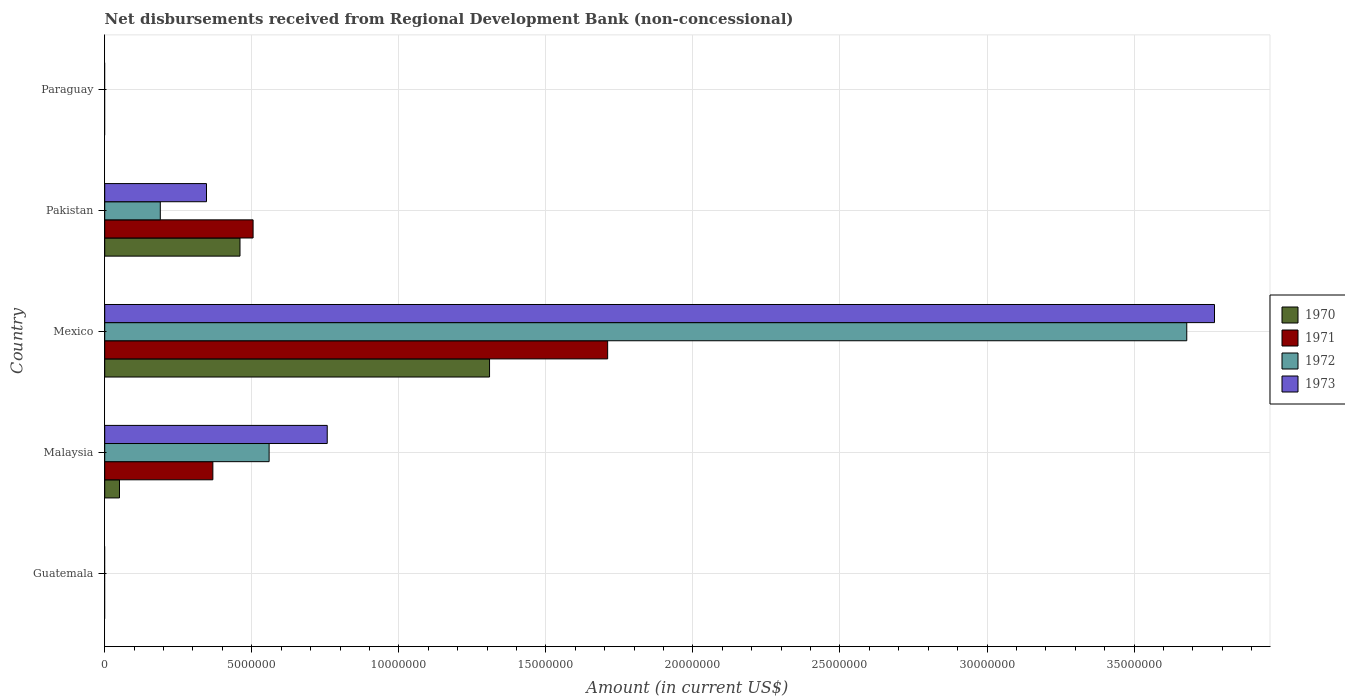Are the number of bars per tick equal to the number of legend labels?
Offer a terse response. No. How many bars are there on the 2nd tick from the top?
Ensure brevity in your answer.  4. What is the label of the 3rd group of bars from the top?
Ensure brevity in your answer.  Mexico. In how many cases, is the number of bars for a given country not equal to the number of legend labels?
Your answer should be compact. 2. What is the amount of disbursements received from Regional Development Bank in 1973 in Malaysia?
Make the answer very short. 7.57e+06. Across all countries, what is the maximum amount of disbursements received from Regional Development Bank in 1970?
Your answer should be very brief. 1.31e+07. In which country was the amount of disbursements received from Regional Development Bank in 1970 maximum?
Your answer should be compact. Mexico. What is the total amount of disbursements received from Regional Development Bank in 1970 in the graph?
Make the answer very short. 1.82e+07. What is the difference between the amount of disbursements received from Regional Development Bank in 1972 in Malaysia and that in Mexico?
Make the answer very short. -3.12e+07. What is the difference between the amount of disbursements received from Regional Development Bank in 1971 in Guatemala and the amount of disbursements received from Regional Development Bank in 1973 in Paraguay?
Give a very brief answer. 0. What is the average amount of disbursements received from Regional Development Bank in 1971 per country?
Make the answer very short. 5.16e+06. What is the difference between the amount of disbursements received from Regional Development Bank in 1970 and amount of disbursements received from Regional Development Bank in 1973 in Malaysia?
Offer a terse response. -7.06e+06. What is the ratio of the amount of disbursements received from Regional Development Bank in 1971 in Malaysia to that in Pakistan?
Give a very brief answer. 0.73. What is the difference between the highest and the second highest amount of disbursements received from Regional Development Bank in 1971?
Your response must be concise. 1.21e+07. What is the difference between the highest and the lowest amount of disbursements received from Regional Development Bank in 1971?
Provide a short and direct response. 1.71e+07. Is it the case that in every country, the sum of the amount of disbursements received from Regional Development Bank in 1973 and amount of disbursements received from Regional Development Bank in 1970 is greater than the sum of amount of disbursements received from Regional Development Bank in 1971 and amount of disbursements received from Regional Development Bank in 1972?
Provide a short and direct response. No. What is the difference between two consecutive major ticks on the X-axis?
Your answer should be very brief. 5.00e+06. Does the graph contain any zero values?
Make the answer very short. Yes. How many legend labels are there?
Offer a very short reply. 4. How are the legend labels stacked?
Make the answer very short. Vertical. What is the title of the graph?
Give a very brief answer. Net disbursements received from Regional Development Bank (non-concessional). Does "2007" appear as one of the legend labels in the graph?
Give a very brief answer. No. What is the label or title of the X-axis?
Provide a succinct answer. Amount (in current US$). What is the Amount (in current US$) of 1970 in Guatemala?
Provide a short and direct response. 0. What is the Amount (in current US$) in 1973 in Guatemala?
Your answer should be very brief. 0. What is the Amount (in current US$) of 1970 in Malaysia?
Provide a succinct answer. 5.02e+05. What is the Amount (in current US$) in 1971 in Malaysia?
Your response must be concise. 3.68e+06. What is the Amount (in current US$) of 1972 in Malaysia?
Offer a very short reply. 5.59e+06. What is the Amount (in current US$) of 1973 in Malaysia?
Offer a terse response. 7.57e+06. What is the Amount (in current US$) in 1970 in Mexico?
Your answer should be compact. 1.31e+07. What is the Amount (in current US$) in 1971 in Mexico?
Offer a very short reply. 1.71e+07. What is the Amount (in current US$) in 1972 in Mexico?
Keep it short and to the point. 3.68e+07. What is the Amount (in current US$) of 1973 in Mexico?
Your response must be concise. 3.77e+07. What is the Amount (in current US$) of 1970 in Pakistan?
Provide a short and direct response. 4.60e+06. What is the Amount (in current US$) in 1971 in Pakistan?
Your response must be concise. 5.04e+06. What is the Amount (in current US$) of 1972 in Pakistan?
Offer a very short reply. 1.89e+06. What is the Amount (in current US$) of 1973 in Pakistan?
Keep it short and to the point. 3.46e+06. What is the Amount (in current US$) in 1972 in Paraguay?
Provide a short and direct response. 0. What is the Amount (in current US$) in 1973 in Paraguay?
Give a very brief answer. 0. Across all countries, what is the maximum Amount (in current US$) in 1970?
Offer a terse response. 1.31e+07. Across all countries, what is the maximum Amount (in current US$) of 1971?
Provide a succinct answer. 1.71e+07. Across all countries, what is the maximum Amount (in current US$) in 1972?
Give a very brief answer. 3.68e+07. Across all countries, what is the maximum Amount (in current US$) in 1973?
Make the answer very short. 3.77e+07. Across all countries, what is the minimum Amount (in current US$) of 1970?
Ensure brevity in your answer.  0. Across all countries, what is the minimum Amount (in current US$) of 1972?
Keep it short and to the point. 0. What is the total Amount (in current US$) of 1970 in the graph?
Ensure brevity in your answer.  1.82e+07. What is the total Amount (in current US$) in 1971 in the graph?
Your answer should be very brief. 2.58e+07. What is the total Amount (in current US$) of 1972 in the graph?
Keep it short and to the point. 4.43e+07. What is the total Amount (in current US$) of 1973 in the graph?
Give a very brief answer. 4.88e+07. What is the difference between the Amount (in current US$) of 1970 in Malaysia and that in Mexico?
Your response must be concise. -1.26e+07. What is the difference between the Amount (in current US$) of 1971 in Malaysia and that in Mexico?
Keep it short and to the point. -1.34e+07. What is the difference between the Amount (in current US$) of 1972 in Malaysia and that in Mexico?
Provide a short and direct response. -3.12e+07. What is the difference between the Amount (in current US$) of 1973 in Malaysia and that in Mexico?
Your answer should be compact. -3.02e+07. What is the difference between the Amount (in current US$) in 1970 in Malaysia and that in Pakistan?
Offer a terse response. -4.10e+06. What is the difference between the Amount (in current US$) in 1971 in Malaysia and that in Pakistan?
Your answer should be compact. -1.37e+06. What is the difference between the Amount (in current US$) of 1972 in Malaysia and that in Pakistan?
Provide a succinct answer. 3.70e+06. What is the difference between the Amount (in current US$) of 1973 in Malaysia and that in Pakistan?
Your response must be concise. 4.10e+06. What is the difference between the Amount (in current US$) of 1970 in Mexico and that in Pakistan?
Keep it short and to the point. 8.48e+06. What is the difference between the Amount (in current US$) of 1971 in Mexico and that in Pakistan?
Offer a very short reply. 1.21e+07. What is the difference between the Amount (in current US$) in 1972 in Mexico and that in Pakistan?
Offer a very short reply. 3.49e+07. What is the difference between the Amount (in current US$) of 1973 in Mexico and that in Pakistan?
Offer a very short reply. 3.43e+07. What is the difference between the Amount (in current US$) in 1970 in Malaysia and the Amount (in current US$) in 1971 in Mexico?
Provide a short and direct response. -1.66e+07. What is the difference between the Amount (in current US$) of 1970 in Malaysia and the Amount (in current US$) of 1972 in Mexico?
Offer a terse response. -3.63e+07. What is the difference between the Amount (in current US$) of 1970 in Malaysia and the Amount (in current US$) of 1973 in Mexico?
Make the answer very short. -3.72e+07. What is the difference between the Amount (in current US$) in 1971 in Malaysia and the Amount (in current US$) in 1972 in Mexico?
Provide a succinct answer. -3.31e+07. What is the difference between the Amount (in current US$) in 1971 in Malaysia and the Amount (in current US$) in 1973 in Mexico?
Give a very brief answer. -3.41e+07. What is the difference between the Amount (in current US$) of 1972 in Malaysia and the Amount (in current US$) of 1973 in Mexico?
Give a very brief answer. -3.21e+07. What is the difference between the Amount (in current US$) of 1970 in Malaysia and the Amount (in current US$) of 1971 in Pakistan?
Give a very brief answer. -4.54e+06. What is the difference between the Amount (in current US$) in 1970 in Malaysia and the Amount (in current US$) in 1972 in Pakistan?
Keep it short and to the point. -1.39e+06. What is the difference between the Amount (in current US$) in 1970 in Malaysia and the Amount (in current US$) in 1973 in Pakistan?
Provide a succinct answer. -2.96e+06. What is the difference between the Amount (in current US$) in 1971 in Malaysia and the Amount (in current US$) in 1972 in Pakistan?
Offer a terse response. 1.79e+06. What is the difference between the Amount (in current US$) in 1971 in Malaysia and the Amount (in current US$) in 1973 in Pakistan?
Provide a succinct answer. 2.16e+05. What is the difference between the Amount (in current US$) of 1972 in Malaysia and the Amount (in current US$) of 1973 in Pakistan?
Your answer should be compact. 2.13e+06. What is the difference between the Amount (in current US$) of 1970 in Mexico and the Amount (in current US$) of 1971 in Pakistan?
Provide a short and direct response. 8.04e+06. What is the difference between the Amount (in current US$) of 1970 in Mexico and the Amount (in current US$) of 1972 in Pakistan?
Provide a short and direct response. 1.12e+07. What is the difference between the Amount (in current US$) of 1970 in Mexico and the Amount (in current US$) of 1973 in Pakistan?
Keep it short and to the point. 9.62e+06. What is the difference between the Amount (in current US$) of 1971 in Mexico and the Amount (in current US$) of 1972 in Pakistan?
Ensure brevity in your answer.  1.52e+07. What is the difference between the Amount (in current US$) of 1971 in Mexico and the Amount (in current US$) of 1973 in Pakistan?
Your answer should be compact. 1.36e+07. What is the difference between the Amount (in current US$) in 1972 in Mexico and the Amount (in current US$) in 1973 in Pakistan?
Offer a very short reply. 3.33e+07. What is the average Amount (in current US$) of 1970 per country?
Give a very brief answer. 3.64e+06. What is the average Amount (in current US$) of 1971 per country?
Keep it short and to the point. 5.16e+06. What is the average Amount (in current US$) of 1972 per country?
Provide a succinct answer. 8.85e+06. What is the average Amount (in current US$) in 1973 per country?
Provide a succinct answer. 9.75e+06. What is the difference between the Amount (in current US$) in 1970 and Amount (in current US$) in 1971 in Malaysia?
Offer a very short reply. -3.18e+06. What is the difference between the Amount (in current US$) in 1970 and Amount (in current US$) in 1972 in Malaysia?
Give a very brief answer. -5.09e+06. What is the difference between the Amount (in current US$) in 1970 and Amount (in current US$) in 1973 in Malaysia?
Keep it short and to the point. -7.06e+06. What is the difference between the Amount (in current US$) in 1971 and Amount (in current US$) in 1972 in Malaysia?
Ensure brevity in your answer.  -1.91e+06. What is the difference between the Amount (in current US$) in 1971 and Amount (in current US$) in 1973 in Malaysia?
Give a very brief answer. -3.89e+06. What is the difference between the Amount (in current US$) of 1972 and Amount (in current US$) of 1973 in Malaysia?
Give a very brief answer. -1.98e+06. What is the difference between the Amount (in current US$) in 1970 and Amount (in current US$) in 1971 in Mexico?
Provide a succinct answer. -4.02e+06. What is the difference between the Amount (in current US$) in 1970 and Amount (in current US$) in 1972 in Mexico?
Give a very brief answer. -2.37e+07. What is the difference between the Amount (in current US$) of 1970 and Amount (in current US$) of 1973 in Mexico?
Keep it short and to the point. -2.46e+07. What is the difference between the Amount (in current US$) in 1971 and Amount (in current US$) in 1972 in Mexico?
Make the answer very short. -1.97e+07. What is the difference between the Amount (in current US$) in 1971 and Amount (in current US$) in 1973 in Mexico?
Offer a very short reply. -2.06e+07. What is the difference between the Amount (in current US$) in 1972 and Amount (in current US$) in 1973 in Mexico?
Provide a short and direct response. -9.43e+05. What is the difference between the Amount (in current US$) of 1970 and Amount (in current US$) of 1971 in Pakistan?
Provide a short and direct response. -4.45e+05. What is the difference between the Amount (in current US$) of 1970 and Amount (in current US$) of 1972 in Pakistan?
Provide a short and direct response. 2.71e+06. What is the difference between the Amount (in current US$) in 1970 and Amount (in current US$) in 1973 in Pakistan?
Your answer should be very brief. 1.14e+06. What is the difference between the Amount (in current US$) of 1971 and Amount (in current US$) of 1972 in Pakistan?
Your response must be concise. 3.16e+06. What is the difference between the Amount (in current US$) of 1971 and Amount (in current US$) of 1973 in Pakistan?
Your response must be concise. 1.58e+06. What is the difference between the Amount (in current US$) of 1972 and Amount (in current US$) of 1973 in Pakistan?
Keep it short and to the point. -1.57e+06. What is the ratio of the Amount (in current US$) of 1970 in Malaysia to that in Mexico?
Give a very brief answer. 0.04. What is the ratio of the Amount (in current US$) in 1971 in Malaysia to that in Mexico?
Make the answer very short. 0.21. What is the ratio of the Amount (in current US$) of 1972 in Malaysia to that in Mexico?
Offer a terse response. 0.15. What is the ratio of the Amount (in current US$) of 1973 in Malaysia to that in Mexico?
Your answer should be compact. 0.2. What is the ratio of the Amount (in current US$) of 1970 in Malaysia to that in Pakistan?
Your response must be concise. 0.11. What is the ratio of the Amount (in current US$) in 1971 in Malaysia to that in Pakistan?
Keep it short and to the point. 0.73. What is the ratio of the Amount (in current US$) of 1972 in Malaysia to that in Pakistan?
Make the answer very short. 2.96. What is the ratio of the Amount (in current US$) in 1973 in Malaysia to that in Pakistan?
Give a very brief answer. 2.19. What is the ratio of the Amount (in current US$) in 1970 in Mexico to that in Pakistan?
Your response must be concise. 2.84. What is the ratio of the Amount (in current US$) of 1971 in Mexico to that in Pakistan?
Offer a very short reply. 3.39. What is the ratio of the Amount (in current US$) of 1972 in Mexico to that in Pakistan?
Ensure brevity in your answer.  19.47. What is the ratio of the Amount (in current US$) in 1973 in Mexico to that in Pakistan?
Keep it short and to the point. 10.9. What is the difference between the highest and the second highest Amount (in current US$) in 1970?
Your answer should be very brief. 8.48e+06. What is the difference between the highest and the second highest Amount (in current US$) of 1971?
Keep it short and to the point. 1.21e+07. What is the difference between the highest and the second highest Amount (in current US$) of 1972?
Your response must be concise. 3.12e+07. What is the difference between the highest and the second highest Amount (in current US$) of 1973?
Provide a succinct answer. 3.02e+07. What is the difference between the highest and the lowest Amount (in current US$) of 1970?
Your response must be concise. 1.31e+07. What is the difference between the highest and the lowest Amount (in current US$) of 1971?
Keep it short and to the point. 1.71e+07. What is the difference between the highest and the lowest Amount (in current US$) of 1972?
Your answer should be compact. 3.68e+07. What is the difference between the highest and the lowest Amount (in current US$) in 1973?
Your answer should be very brief. 3.77e+07. 